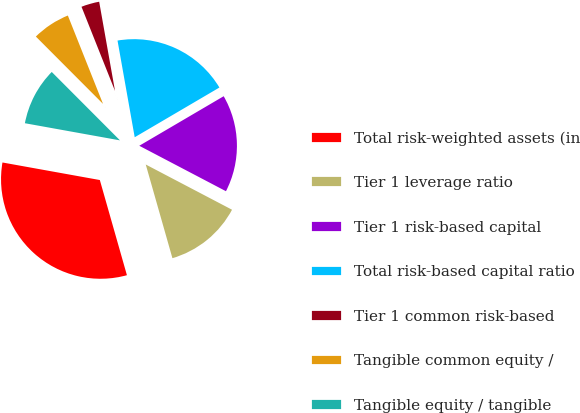Convert chart to OTSL. <chart><loc_0><loc_0><loc_500><loc_500><pie_chart><fcel>Total risk-weighted assets (in<fcel>Tier 1 leverage ratio<fcel>Tier 1 risk-based capital<fcel>Total risk-based capital ratio<fcel>Tier 1 common risk-based<fcel>Tangible common equity /<fcel>Tangible equity / tangible<nl><fcel>32.25%<fcel>12.9%<fcel>16.13%<fcel>19.35%<fcel>3.23%<fcel>6.45%<fcel>9.68%<nl></chart> 